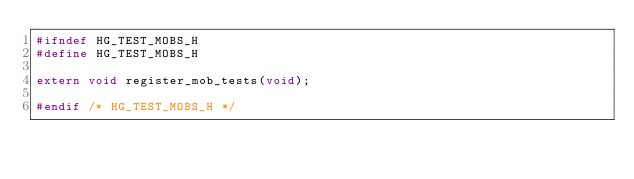Convert code to text. <code><loc_0><loc_0><loc_500><loc_500><_C_>#ifndef HG_TEST_MOBS_H
#define HG_TEST_MOBS_H

extern void register_mob_tests(void);

#endif /* HG_TEST_MOBS_H */
</code> 